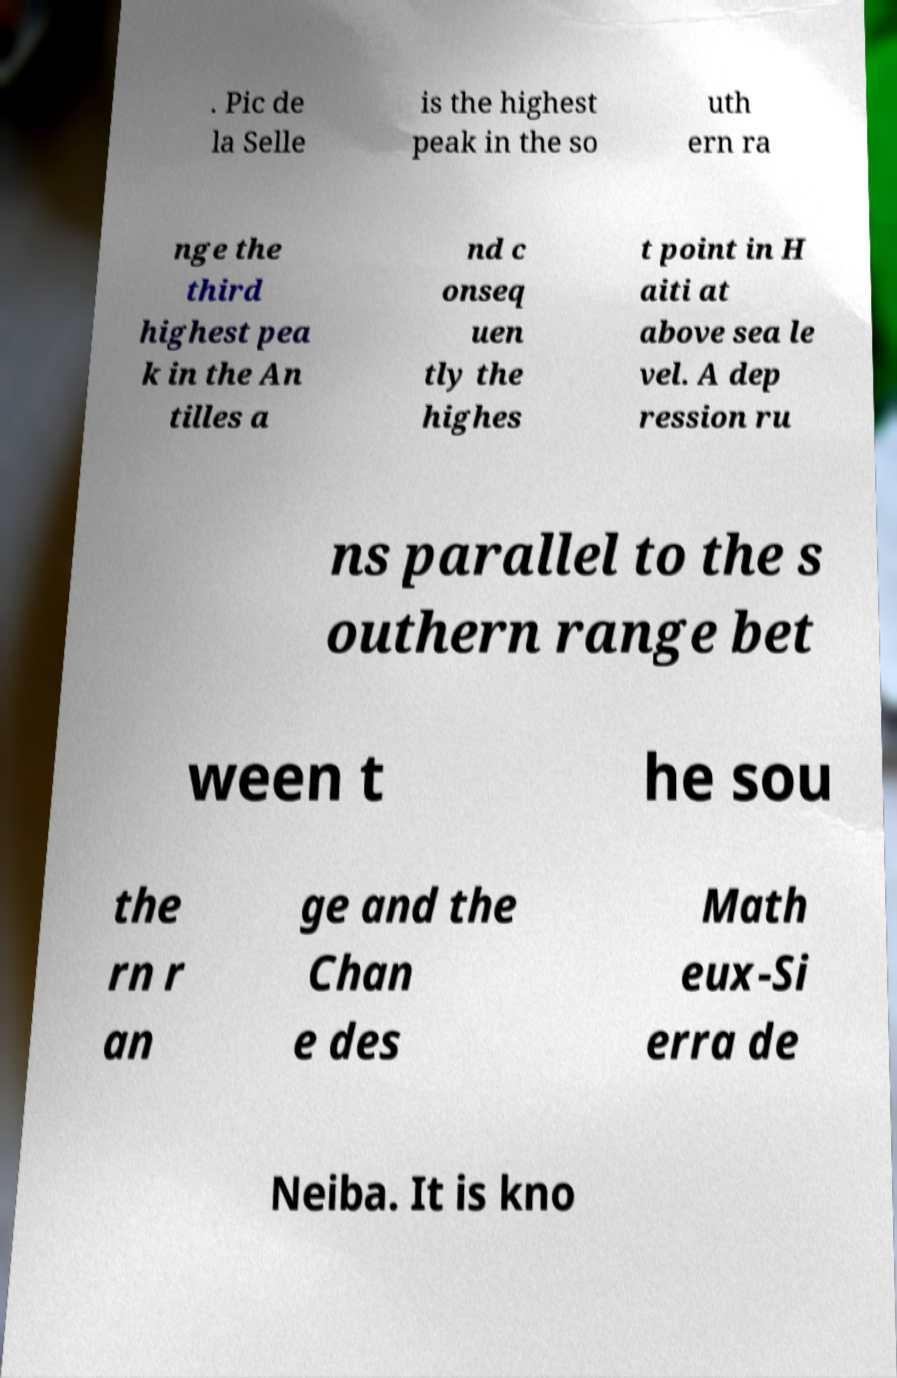Please read and relay the text visible in this image. What does it say? . Pic de la Selle is the highest peak in the so uth ern ra nge the third highest pea k in the An tilles a nd c onseq uen tly the highes t point in H aiti at above sea le vel. A dep ression ru ns parallel to the s outhern range bet ween t he sou the rn r an ge and the Chan e des Math eux-Si erra de Neiba. It is kno 